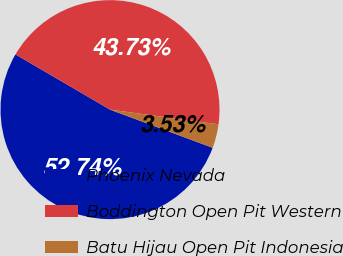Convert chart to OTSL. <chart><loc_0><loc_0><loc_500><loc_500><pie_chart><fcel>Phoenix Nevada<fcel>Boddington Open Pit Western<fcel>Batu Hijau Open Pit Indonesia<nl><fcel>52.75%<fcel>43.73%<fcel>3.53%<nl></chart> 